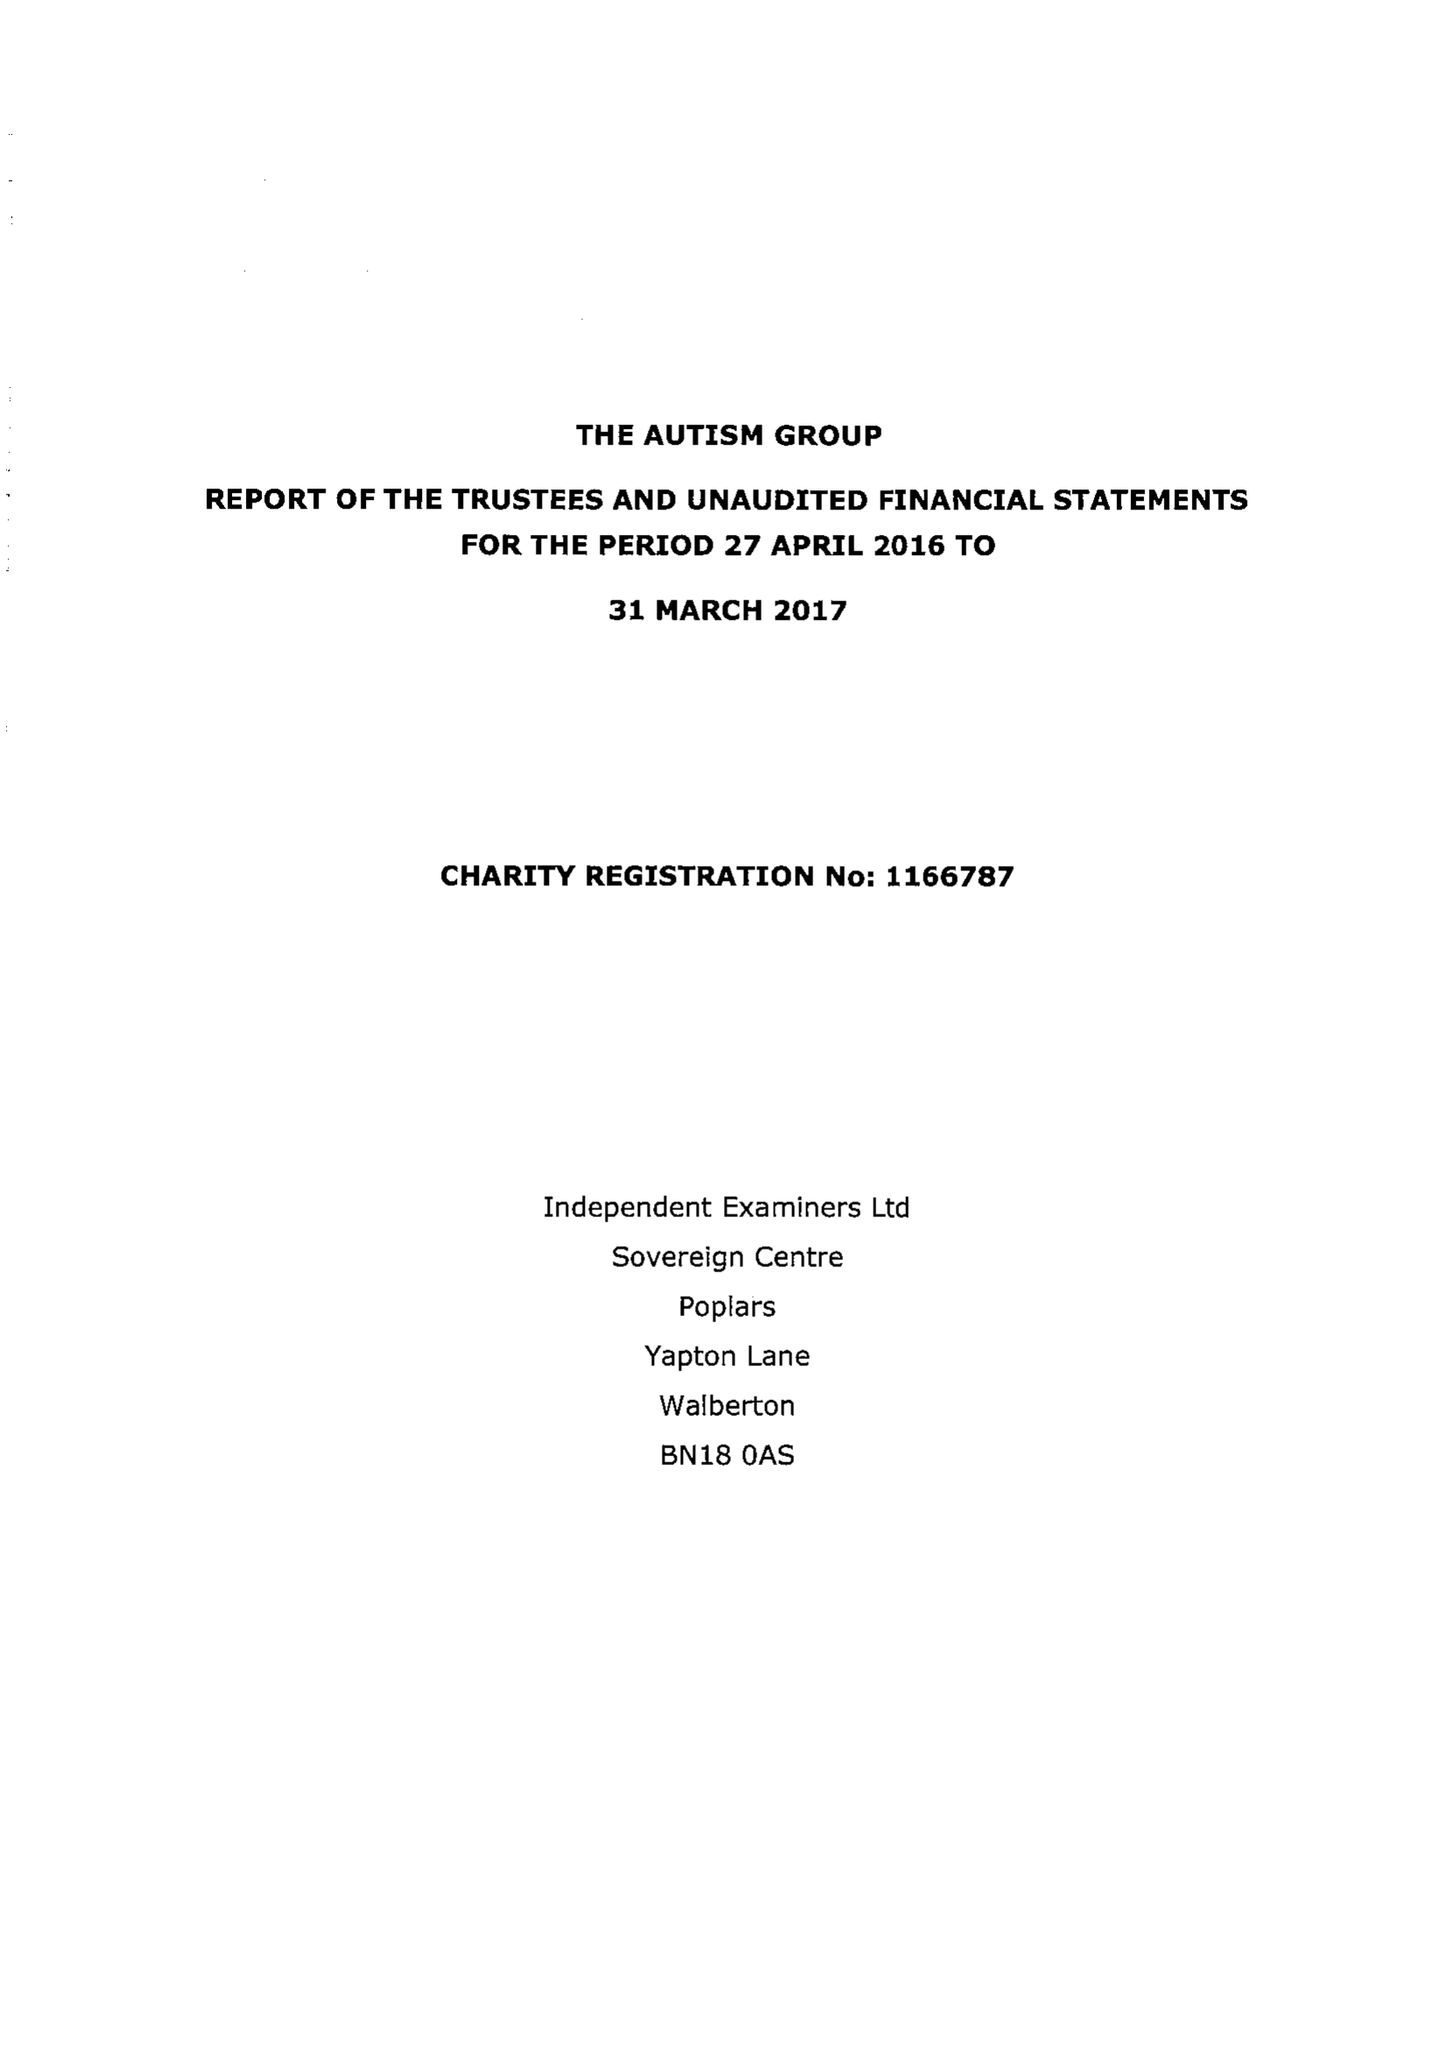What is the value for the spending_annually_in_british_pounds?
Answer the question using a single word or phrase. 24685.00 